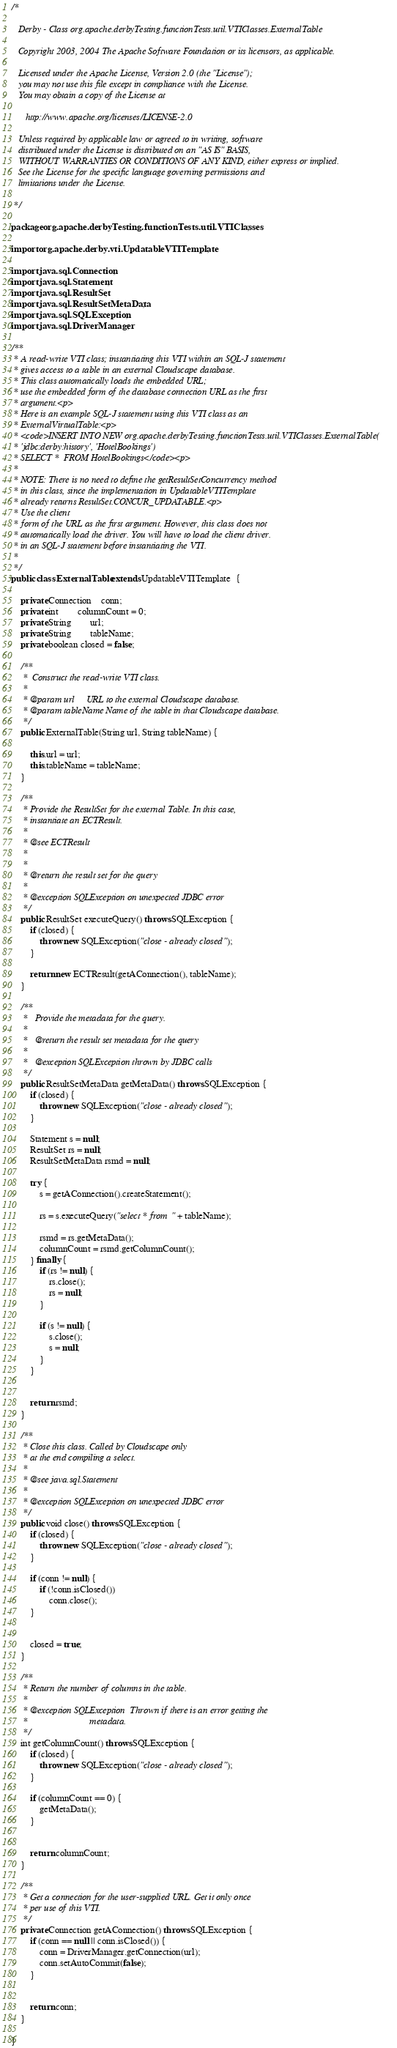<code> <loc_0><loc_0><loc_500><loc_500><_Java_>/*

   Derby - Class org.apache.derbyTesting.functionTests.util.VTIClasses.ExternalTable

   Copyright 2003, 2004 The Apache Software Foundation or its licensors, as applicable.

   Licensed under the Apache License, Version 2.0 (the "License");
   you may not use this file except in compliance with the License.
   You may obtain a copy of the License at

      http://www.apache.org/licenses/LICENSE-2.0

   Unless required by applicable law or agreed to in writing, software
   distributed under the License is distributed on an "AS IS" BASIS,
   WITHOUT WARRANTIES OR CONDITIONS OF ANY KIND, either express or implied.
   See the License for the specific language governing permissions and
   limitations under the License.

 */

package org.apache.derbyTesting.functionTests.util.VTIClasses;

import org.apache.derby.vti.UpdatableVTITemplate;

import java.sql.Connection;
import java.sql.Statement;
import java.sql.ResultSet;
import java.sql.ResultSetMetaData;
import java.sql.SQLException;
import java.sql.DriverManager;

/**
 * A read-write VTI class; instantiating this VTI within an SQL-J statement
 * gives access to a table in an external Cloudscape database.
 * This class automatically loads the embedded URL;
 * use the embedded form of the database connection URL as the first
 * argument.<p>
 * Here is an example SQL-J statement using this VTI class as an
 * ExternalVirtualTable:<p>
 * <code>INSERT INTO NEW org.apache.derbyTesting.functionTests.util.VTIClasses.ExternalTable(
 * 'jdbc:derby:history', 'HotelBookings')
 * SELECT *  FROM HotelBookings</code><p>
 *
 * NOTE: There is no need to define the getResultSetConcurrency method
 * in this class, since the implementation in UpdatableVTITemplate 
 * already returns ResultSet.CONCUR_UPDATABLE.<p>
 * Use the client
 * form of the URL as the first argument. However, this class does not
 * automatically load the driver. You will have to load the client driver.
 * in an SQL-J statement before instantiating the VTI. 
 *
 */
public class ExternalTable extends UpdatableVTITemplate  {

	private Connection	conn;
	private int		columnCount = 0;
	private String		url;
	private String		tableName;
	private boolean closed = false;

	/**
	 *  Construct the read-write VTI class.
	 *
	 * @param url     URL to the external Cloudscape database.
     * @param tableName Name of the table in that Cloudscape database.
	 */
	public ExternalTable(String url, String tableName) {
		
		this.url = url;
		this.tableName = tableName;
	}

	/**
	 * Provide the ResultSet for the external Table. In this case,
	 * instantiate an ECTResult.
	 *
	 * @see ECTResult
	 *
	 *
	 * @return the result set for the query
	 *
 	 * @exception SQLException on unexpected JDBC error
	 */
	public ResultSet executeQuery() throws SQLException {
		if (closed) {
	        throw new SQLException("close - already closed");
		}
		
		return new ECTResult(getAConnection(), tableName);
	}

    /**
     *   Provide the metadata for the query.
     *
     *   @return the result set metadata for the query
	 *
     *   @exception SQLException thrown by JDBC calls
     */
    public ResultSetMetaData getMetaData() throws SQLException {
		if (closed) {
	        throw new SQLException("close - already closed");
		}

		Statement s = null;
		ResultSet rs = null;
        ResultSetMetaData rsmd = null;

		try {
			s = getAConnection().createStatement();

        	rs = s.executeQuery("select * from " + tableName);

        	rsmd = rs.getMetaData();
			columnCount = rsmd.getColumnCount();
		} finally {
			if (rs != null) {
				rs.close();
				rs = null;
			}

			if (s != null) {
				s.close();
				s = null;
			}
		}
		

        return rsmd;
    }

	/**
	 * Close this class. Called by Cloudscape only
	 * at the end compiling a select.
	 * 
	 * @see java.sql.Statement
	 *
 	 * @exception SQLException on unexpected JDBC error
	 */
	public void close() throws SQLException {
		if (closed) {
	        throw new SQLException("close - already closed");
		}

		if (conn != null) {
			if (!conn.isClosed())
				conn.close();
		}
		

		closed = true;
	}

	/**
	 * Return the number of columns in the table.
	 *
	 * @exception SQLException	Thrown if there is an error getting the
	 *							metadata.
	 */
	int getColumnCount() throws SQLException {
		if (closed) {
	        throw new SQLException("close - already closed");
		}

		if (columnCount == 0) {
			getMetaData();
		}
		

		return columnCount;
	}

	/**
	 * Get a connection for the user-supplied URL. Get it only once
	 * per use of this VTI.
	 */
	private Connection getAConnection() throws SQLException {
		if (conn == null || conn.isClosed()) {
			conn = DriverManager.getConnection(url);
			conn.setAutoCommit(false);
		}


		return conn;
	}

}
</code> 